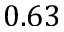<formula> <loc_0><loc_0><loc_500><loc_500>0 . 6 3</formula> 